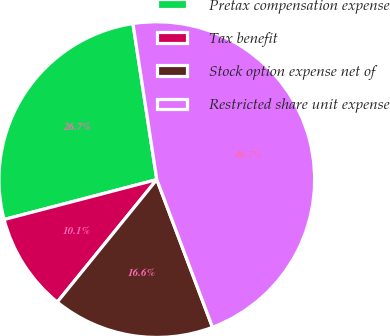Convert chart. <chart><loc_0><loc_0><loc_500><loc_500><pie_chart><fcel>Pretax compensation expense<fcel>Tax benefit<fcel>Stock option expense net of<fcel>Restricted share unit expense<nl><fcel>26.66%<fcel>10.07%<fcel>16.6%<fcel>46.68%<nl></chart> 